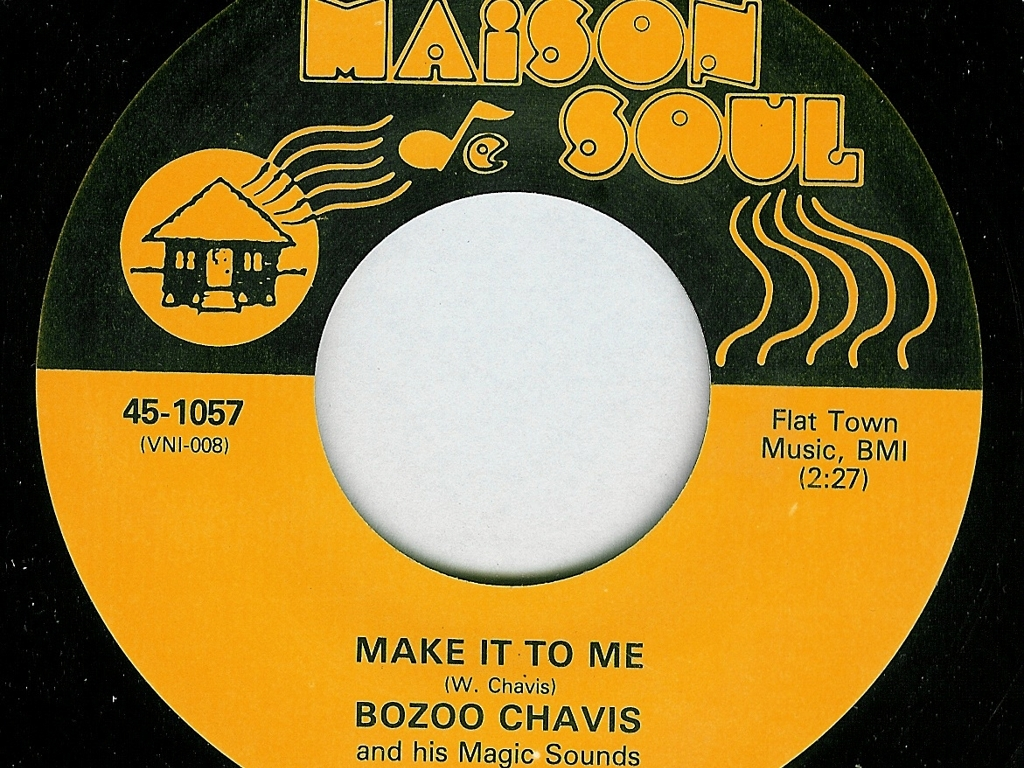Is there any image blur? No, the image appears to be in clear focus with no discernible blur, allowing one to easily read the text and examine the graphic elements on this vintage record label. 